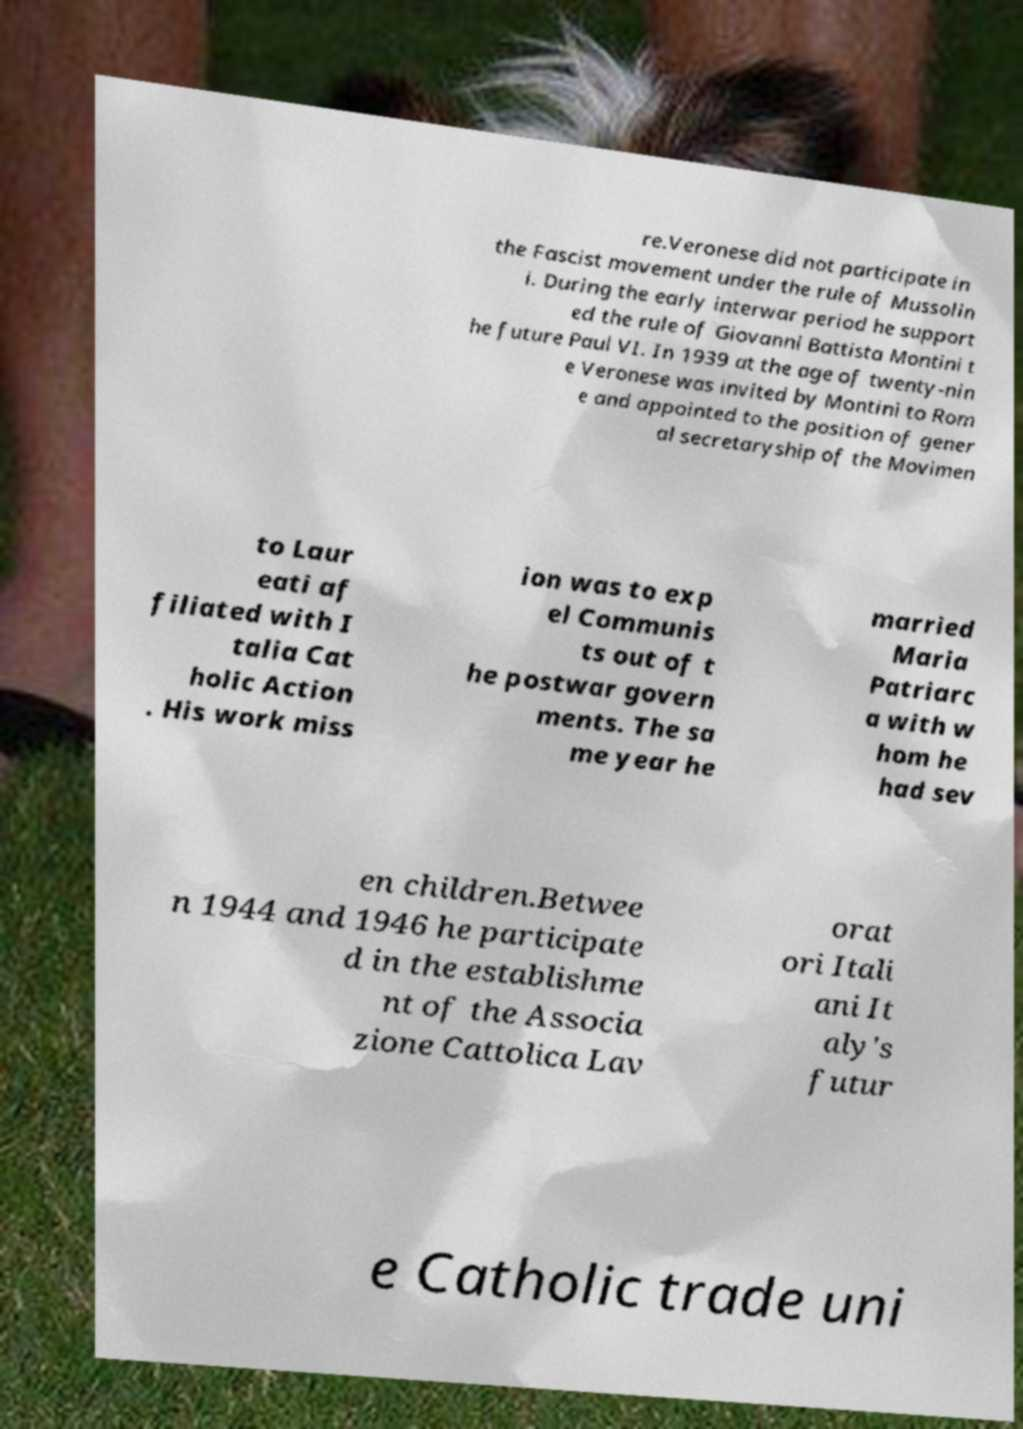Can you read and provide the text displayed in the image?This photo seems to have some interesting text. Can you extract and type it out for me? re.Veronese did not participate in the Fascist movement under the rule of Mussolin i. During the early interwar period he support ed the rule of Giovanni Battista Montini t he future Paul VI. In 1939 at the age of twenty-nin e Veronese was invited by Montini to Rom e and appointed to the position of gener al secretaryship of the Movimen to Laur eati af filiated with I talia Cat holic Action . His work miss ion was to exp el Communis ts out of t he postwar govern ments. The sa me year he married Maria Patriarc a with w hom he had sev en children.Betwee n 1944 and 1946 he participate d in the establishme nt of the Associa zione Cattolica Lav orat ori Itali ani It aly's futur e Catholic trade uni 